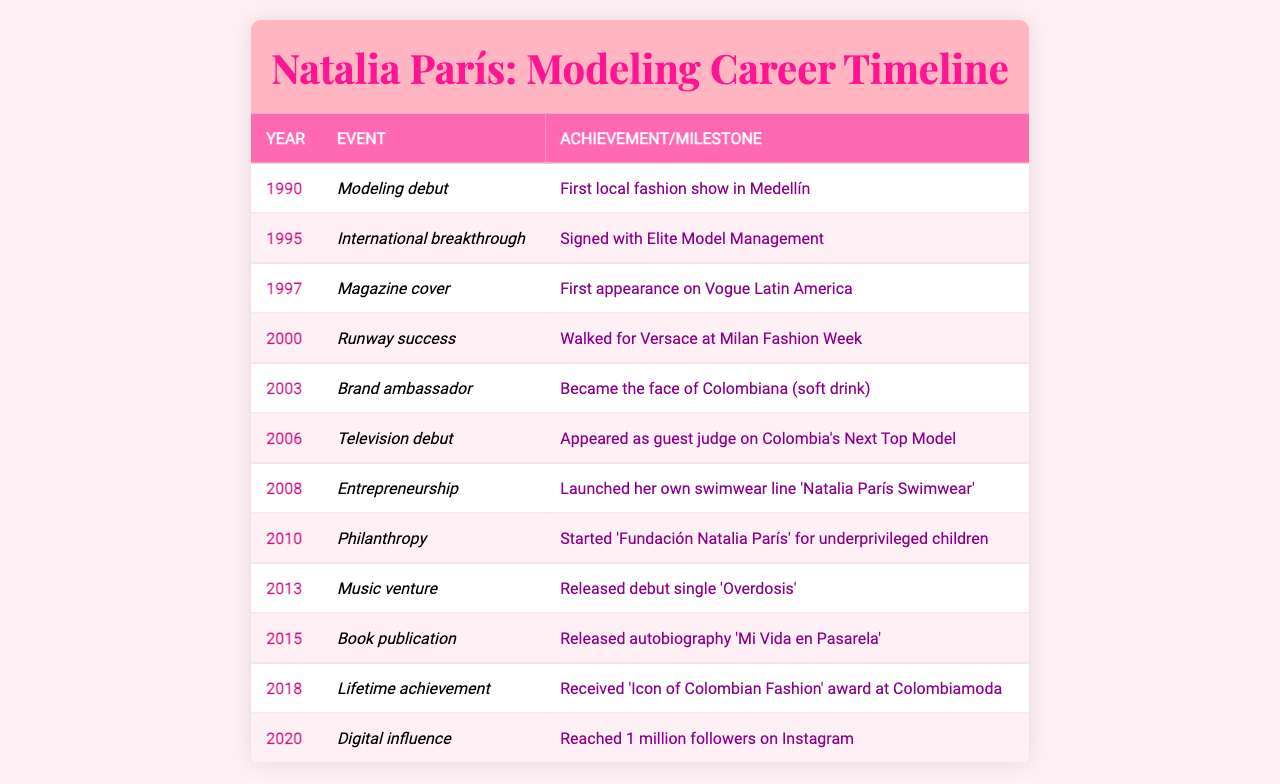What year did Natalia París make her modeling debut? The table indicates that Natalia París made her modeling debut in the year 1990.
Answer: 1990 In which year did Natalia París sign with Elite Model Management? The table shows that Natalia París signed with Elite Model Management in 1995.
Answer: 1995 How many years passed between her modeling debut and her international breakthrough? From 1990 to 1995, 5 years passed (1995 - 1990 = 5).
Answer: 5 years What major achievement did Natalia París accomplish in 2000? The table states that in 2000, Natalia walked for Versace at Milan Fashion Week, which is a significant achievement.
Answer: Walked for Versace at Milan Fashion Week Did Natalia París launch her swimwear line before or after her television debut? According to the table, she launched her swimwear line in 2008, while her television debut occurred in 2006, indicating that she launched it after her debut.
Answer: After What notable award did she receive in 2018? The table details that in 2018, Natalia received the 'Icon of Colombian Fashion' award at Colombiamoda.
Answer: 'Icon of Colombian Fashion' award How many significant events are listed in the timeline? The table lists a total of 12 events from 1990 to 2020, as seen in the rows.
Answer: 12 events In what year did Natalia release her autobiography? The table indicates that Natalia released her autobiography 'Mi Vida en Pasarela' in 2015.
Answer: 2015 Which achievement marked her transition into music? According to the table, her transition into music was marked by the release of her debut single 'Overdosis' in 2013.
Answer: Released debut single 'Overdosis' What is the difference in years between her first Vogue cover and her first appearance on Instagram? The first Vogue cover was in 1997 and her Instagram milestone was in 2020, which is a 23-year difference (2020 - 1997 = 23).
Answer: 23 years Did she become a brand ambassador for Colombiana before or after her experience in Milan Fashion Week? The data indicates she became the brand ambassador for Colombiana in 2003 and walked in Milan Fashion Week in 2000, meaning she achieved the ambassadorship after the Milan event.
Answer: After 